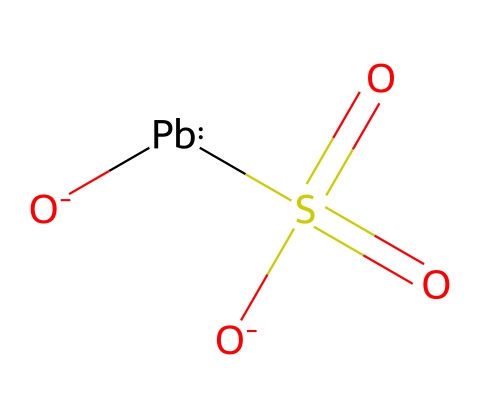What metal is represented in this structure? The chemical SMILES indicates the presence of lead, represented by the symbol [Pb].
Answer: lead How many oxygen atoms are present in the structure? From the SMILES representation, there are three occurrences of the oxygen symbol ([O]), indicating three oxygen atoms.
Answer: three What type of bond connects the lead atom to the sulfate group? The bond between lead [Pb] and the sulfate group starts with a coordinate bond due to lead's ability to accept electrons from the sulfate, indicating a coordination complex.
Answer: coordinate bond What functional group is present in this chemical? The structure contains a sulfate group, indicated by the S(=O)(=O)[O-] part of the SMILES, representing a sulfur atom bonded to three oxygens.
Answer: sulfate group How many total atoms are present in this chemical structure? Counting all unique atoms: 1 lead (Pb), 1 sulfur (S), and 3 oxygen (O) gives a total of 5 atoms.
Answer: five What charge does the sulfate group carry in this chemical? The outer oxygen in the SMILES representation has a negative charge ([O-]), indicating that sulfate carries a -1 charge overall.
Answer: -1 charge What type of battery commonly uses this chemical structure? This chemical structure is characteristic of lead-acid batteries, commonly found in vehicles including classic racing vehicles.
Answer: lead-acid battery 